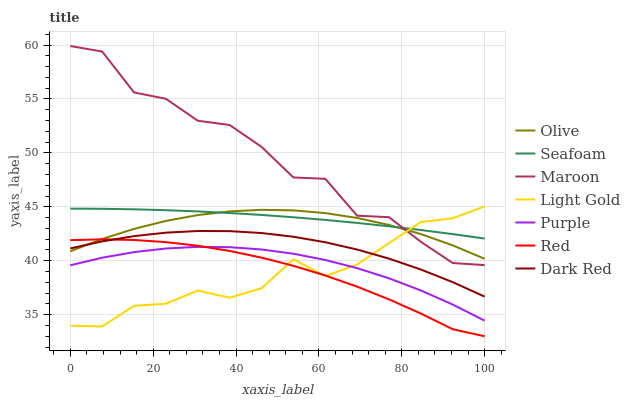Does Light Gold have the minimum area under the curve?
Answer yes or no. Yes. Does Maroon have the maximum area under the curve?
Answer yes or no. Yes. Does Dark Red have the minimum area under the curve?
Answer yes or no. No. Does Dark Red have the maximum area under the curve?
Answer yes or no. No. Is Seafoam the smoothest?
Answer yes or no. Yes. Is Maroon the roughest?
Answer yes or no. Yes. Is Dark Red the smoothest?
Answer yes or no. No. Is Dark Red the roughest?
Answer yes or no. No. Does Red have the lowest value?
Answer yes or no. Yes. Does Dark Red have the lowest value?
Answer yes or no. No. Does Maroon have the highest value?
Answer yes or no. Yes. Does Dark Red have the highest value?
Answer yes or no. No. Is Dark Red less than Seafoam?
Answer yes or no. Yes. Is Seafoam greater than Red?
Answer yes or no. Yes. Does Olive intersect Maroon?
Answer yes or no. Yes. Is Olive less than Maroon?
Answer yes or no. No. Is Olive greater than Maroon?
Answer yes or no. No. Does Dark Red intersect Seafoam?
Answer yes or no. No. 